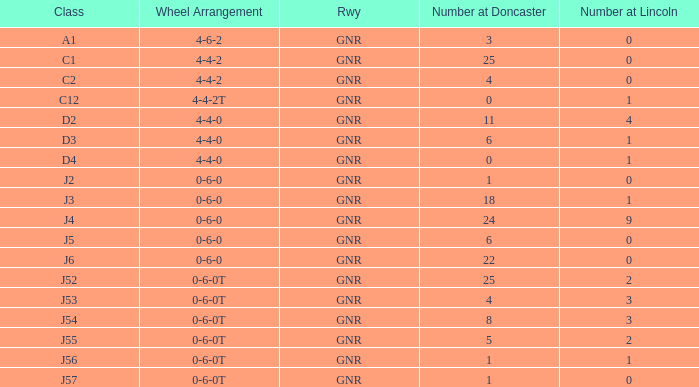Which Class has a Number at Lincoln larger than 0 and a Number at Doncaster of 8? J54. 